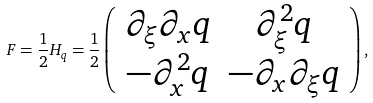Convert formula to latex. <formula><loc_0><loc_0><loc_500><loc_500>F = \frac { 1 } { 2 } H _ { q } = \frac { 1 } { 2 } \left ( \begin{array} { c c } \partial _ { \xi } \partial _ { x } q & \partial _ { \xi } ^ { 2 } q \\ - \partial _ { x } ^ { 2 } q & - \partial _ { x } \partial _ { \xi } q \end{array} \right ) ,</formula> 